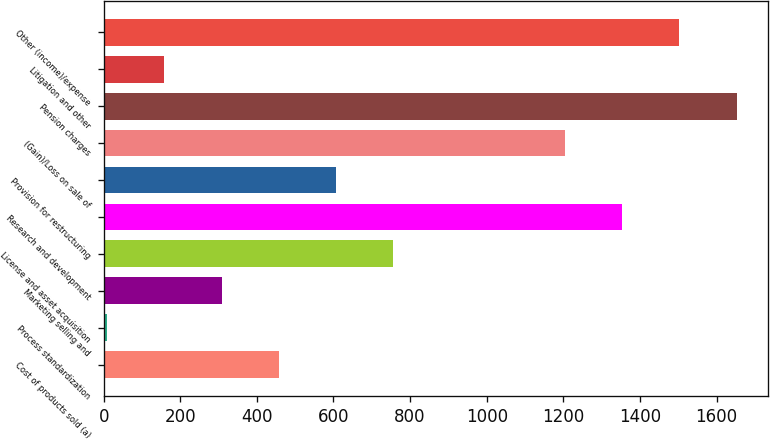<chart> <loc_0><loc_0><loc_500><loc_500><bar_chart><fcel>Cost of products sold (a)<fcel>Process standardization<fcel>Marketing selling and<fcel>License and asset acquisition<fcel>Research and development<fcel>Provision for restructuring<fcel>(Gain)/Loss on sale of<fcel>Pension charges<fcel>Litigation and other<fcel>Other (income)/expense<nl><fcel>457.2<fcel>9<fcel>307.8<fcel>756<fcel>1353.6<fcel>606.6<fcel>1204.2<fcel>1652.4<fcel>158.4<fcel>1503<nl></chart> 